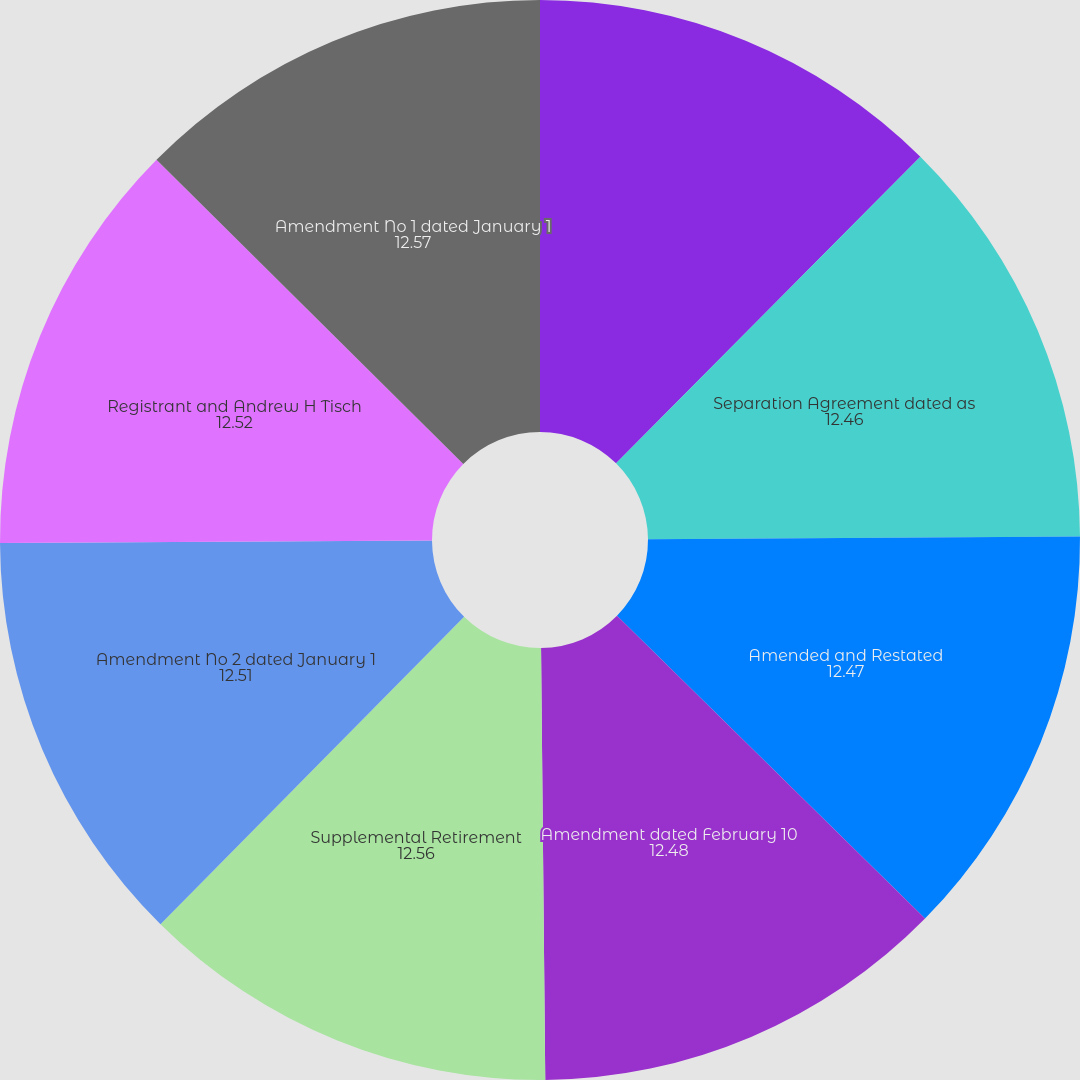<chart> <loc_0><loc_0><loc_500><loc_500><pie_chart><fcel>Loews Corporation 2000 Stock<fcel>Separation Agreement dated as<fcel>Amended and Restated<fcel>Amendment dated February 10<fcel>Supplemental Retirement<fcel>Amendment No 2 dated January 1<fcel>Registrant and Andrew H Tisch<fcel>Amendment No 1 dated January 1<nl><fcel>12.44%<fcel>12.46%<fcel>12.47%<fcel>12.48%<fcel>12.56%<fcel>12.51%<fcel>12.52%<fcel>12.57%<nl></chart> 